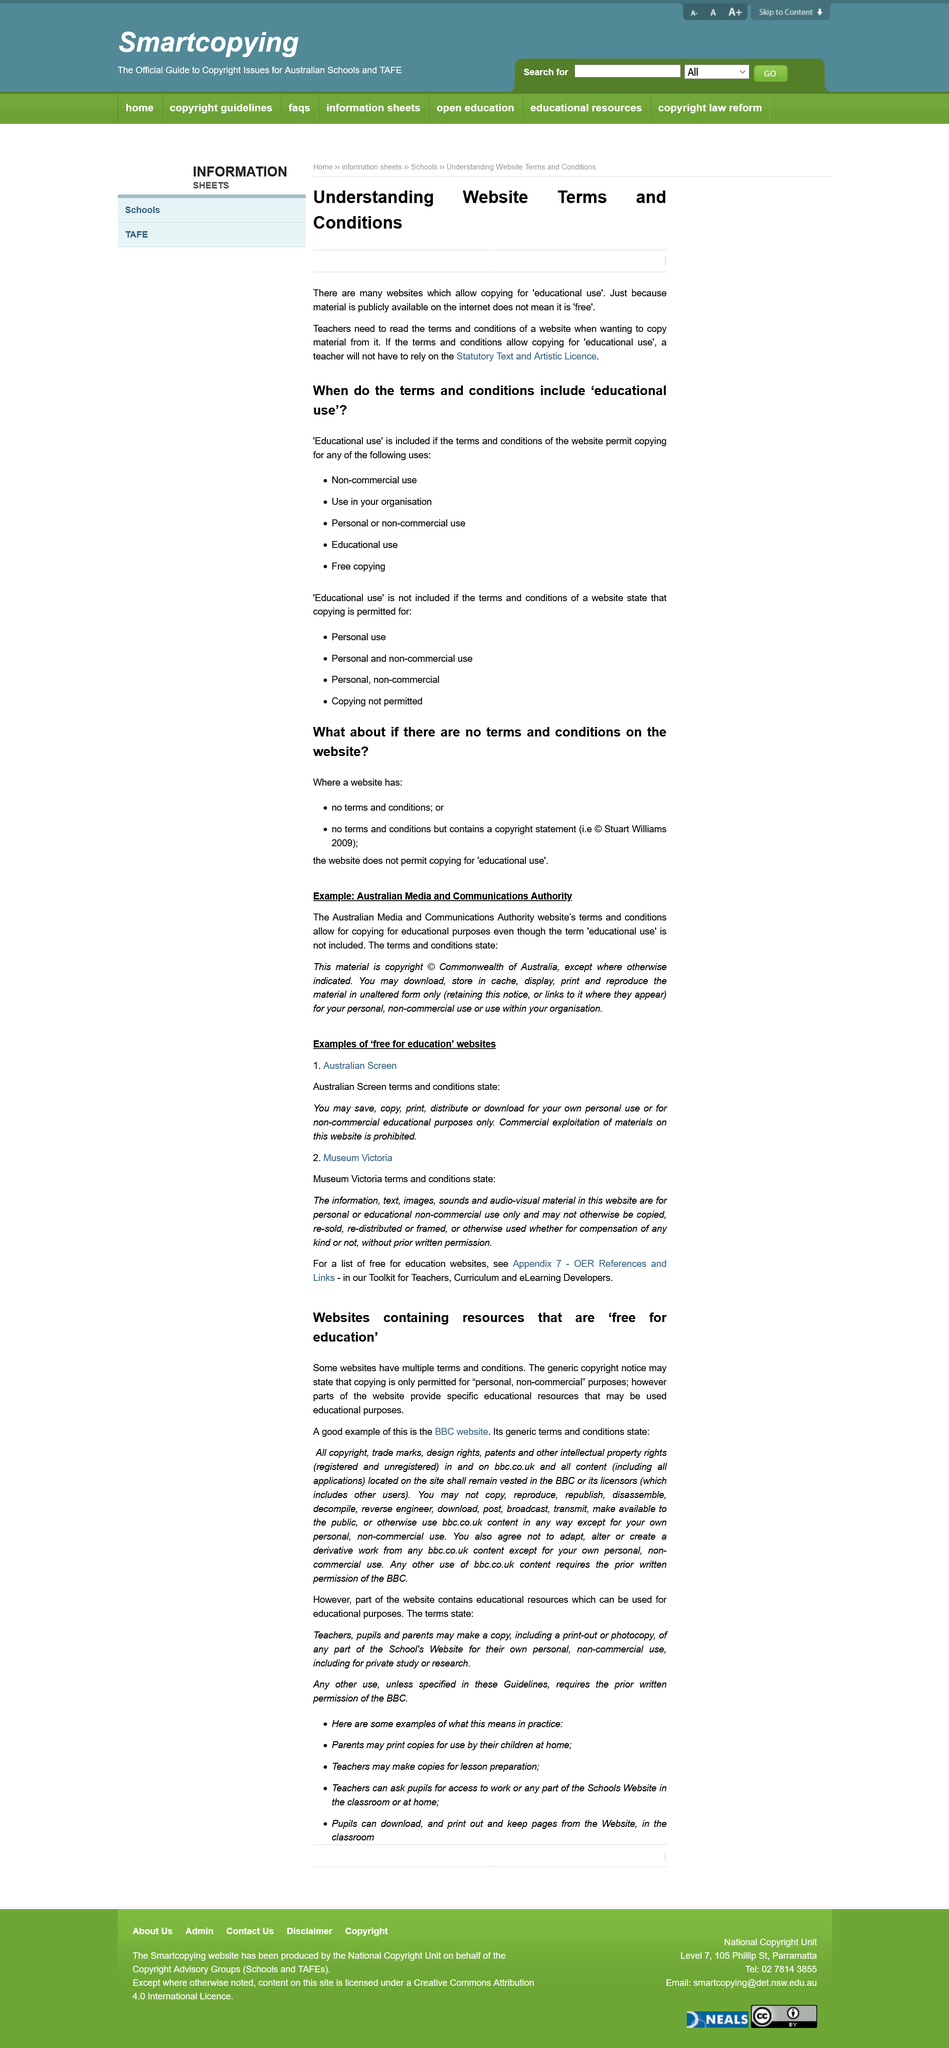Outline some significant characteristics in this image. You may only download, store in cache, display, print, or reproduce the material in its original form, unaltered in any way. It is permissible for a website to be used within an organisation if 'Educational use' is mentioned in its terms and conditions. Commercial exploitation of materials is not allowed under Australian Screen terms and conditions. If material is publicly available on a website, it does not necessarily mean that it is free to use. It is not permissible to republish content found on the BBC website. 